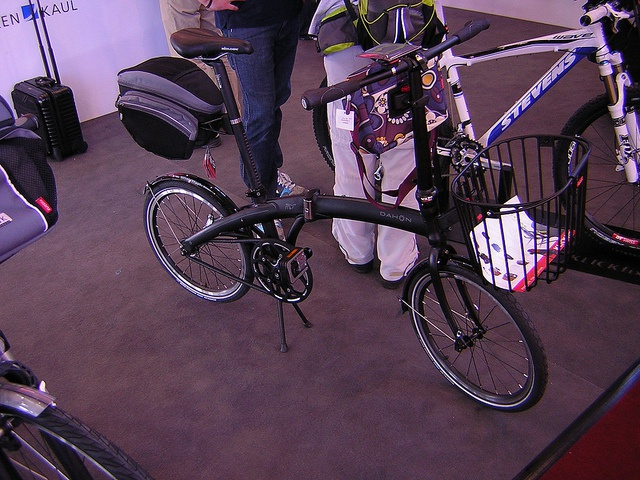Describe the objects in this image and their specific colors. I can see bicycle in violet, black, purple, and navy tones, bicycle in violet, black, and purple tones, people in violet, black, and purple tones, bicycle in violet, black, purple, navy, and gray tones, and handbag in violet, black, and purple tones in this image. 